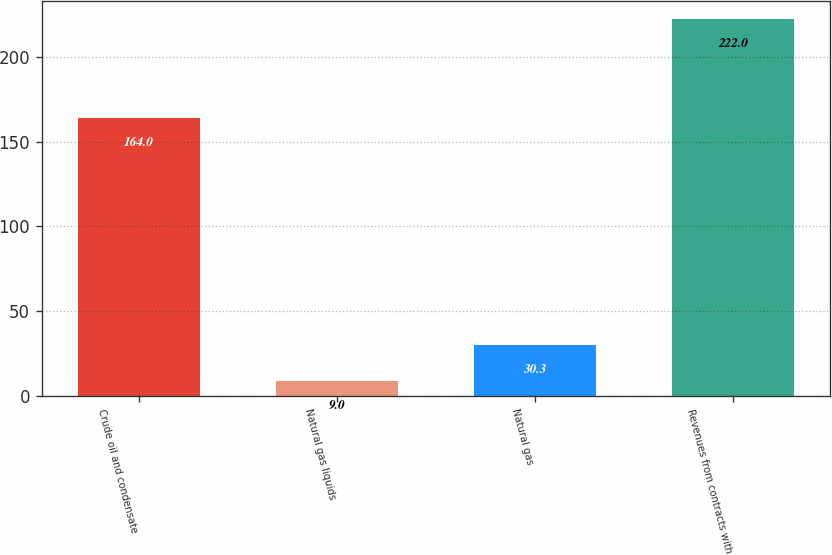Convert chart to OTSL. <chart><loc_0><loc_0><loc_500><loc_500><bar_chart><fcel>Crude oil and condensate<fcel>Natural gas liquids<fcel>Natural gas<fcel>Revenues from contracts with<nl><fcel>164<fcel>9<fcel>30.3<fcel>222<nl></chart> 